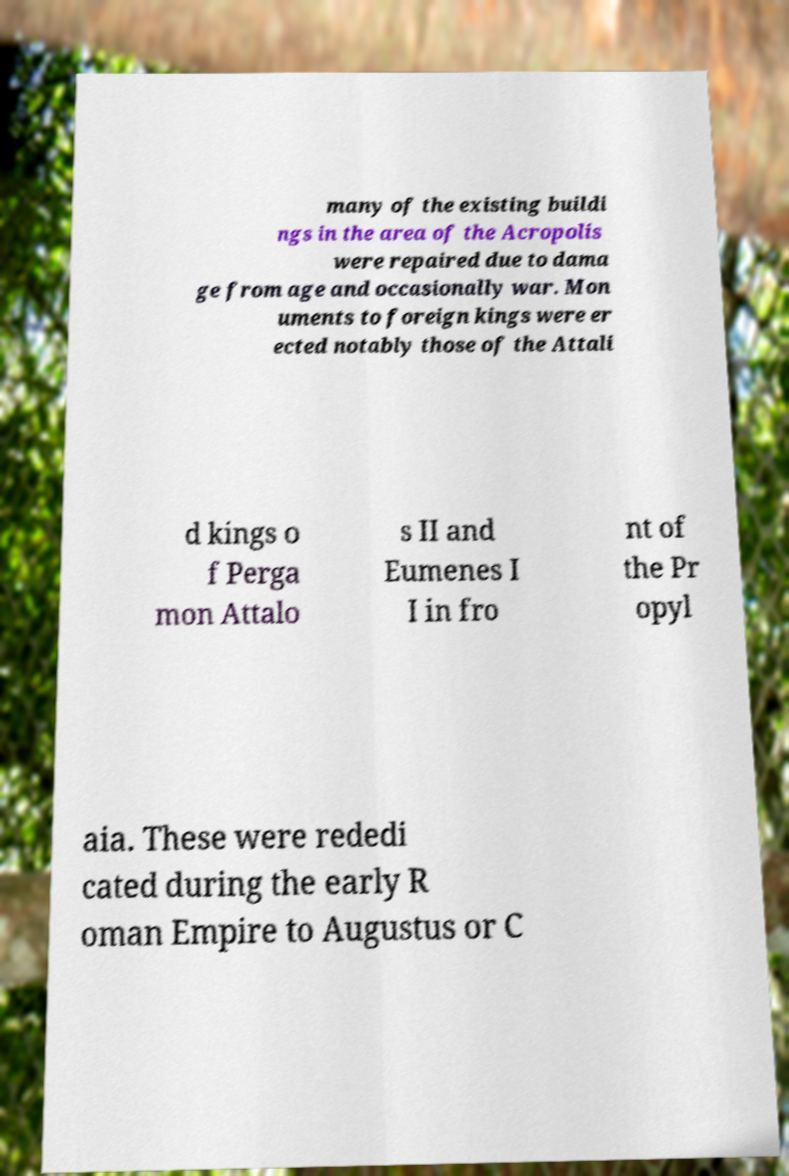Please identify and transcribe the text found in this image. many of the existing buildi ngs in the area of the Acropolis were repaired due to dama ge from age and occasionally war. Mon uments to foreign kings were er ected notably those of the Attali d kings o f Perga mon Attalo s II and Eumenes I I in fro nt of the Pr opyl aia. These were rededi cated during the early R oman Empire to Augustus or C 